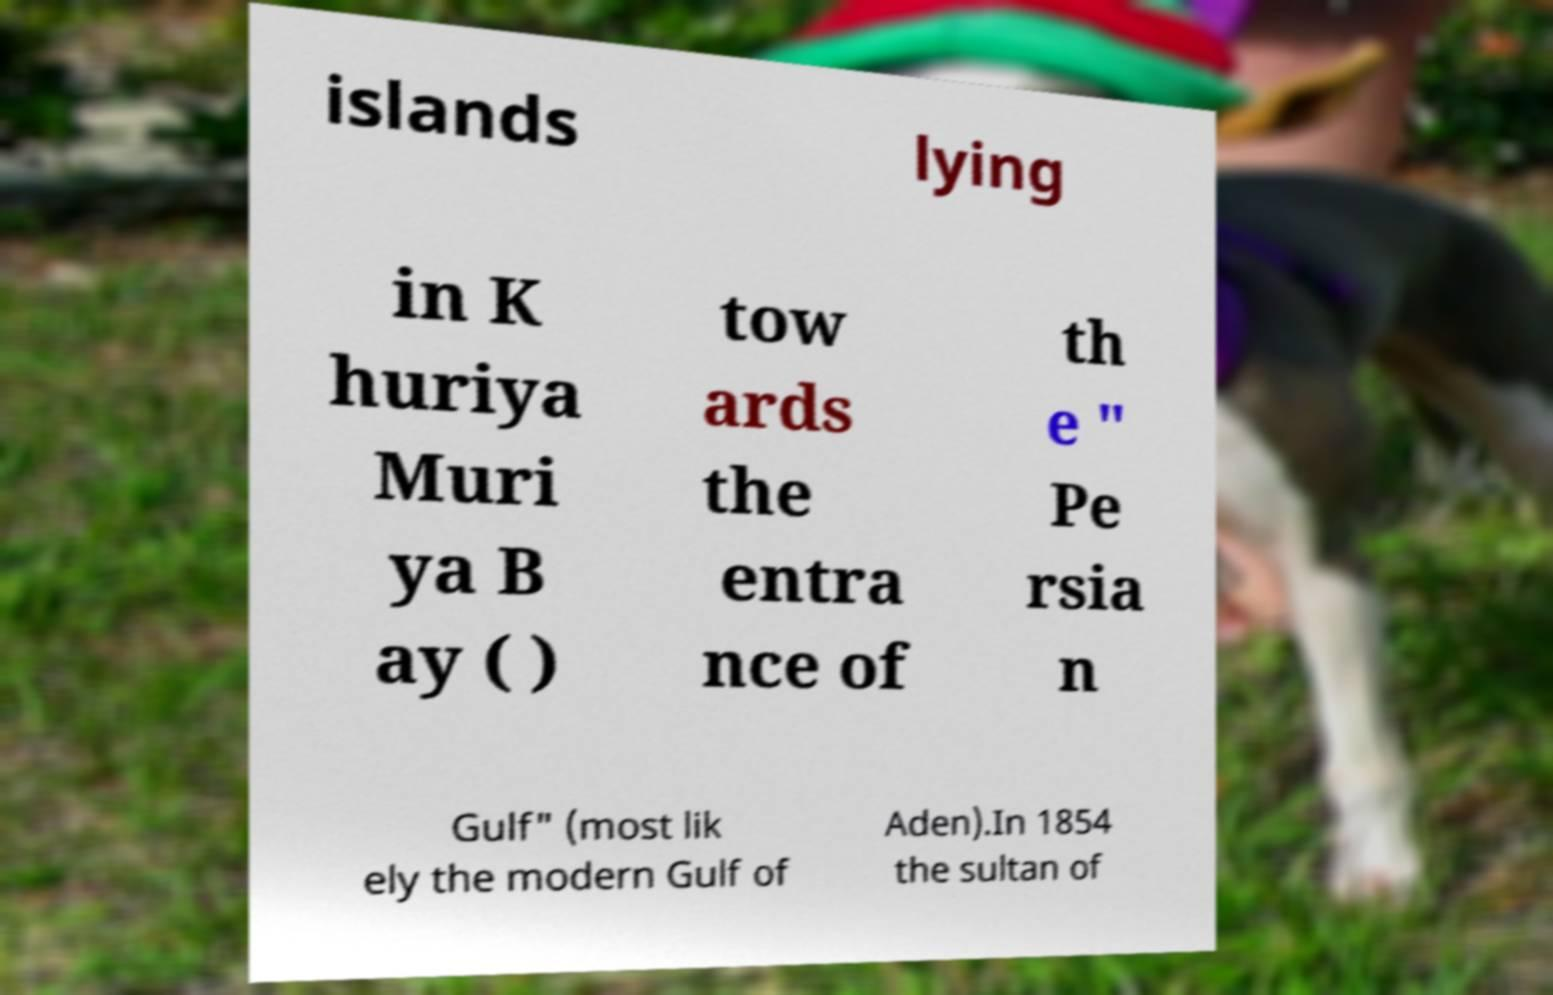I need the written content from this picture converted into text. Can you do that? islands lying in K huriya Muri ya B ay ( ) tow ards the entra nce of th e " Pe rsia n Gulf" (most lik ely the modern Gulf of Aden).In 1854 the sultan of 